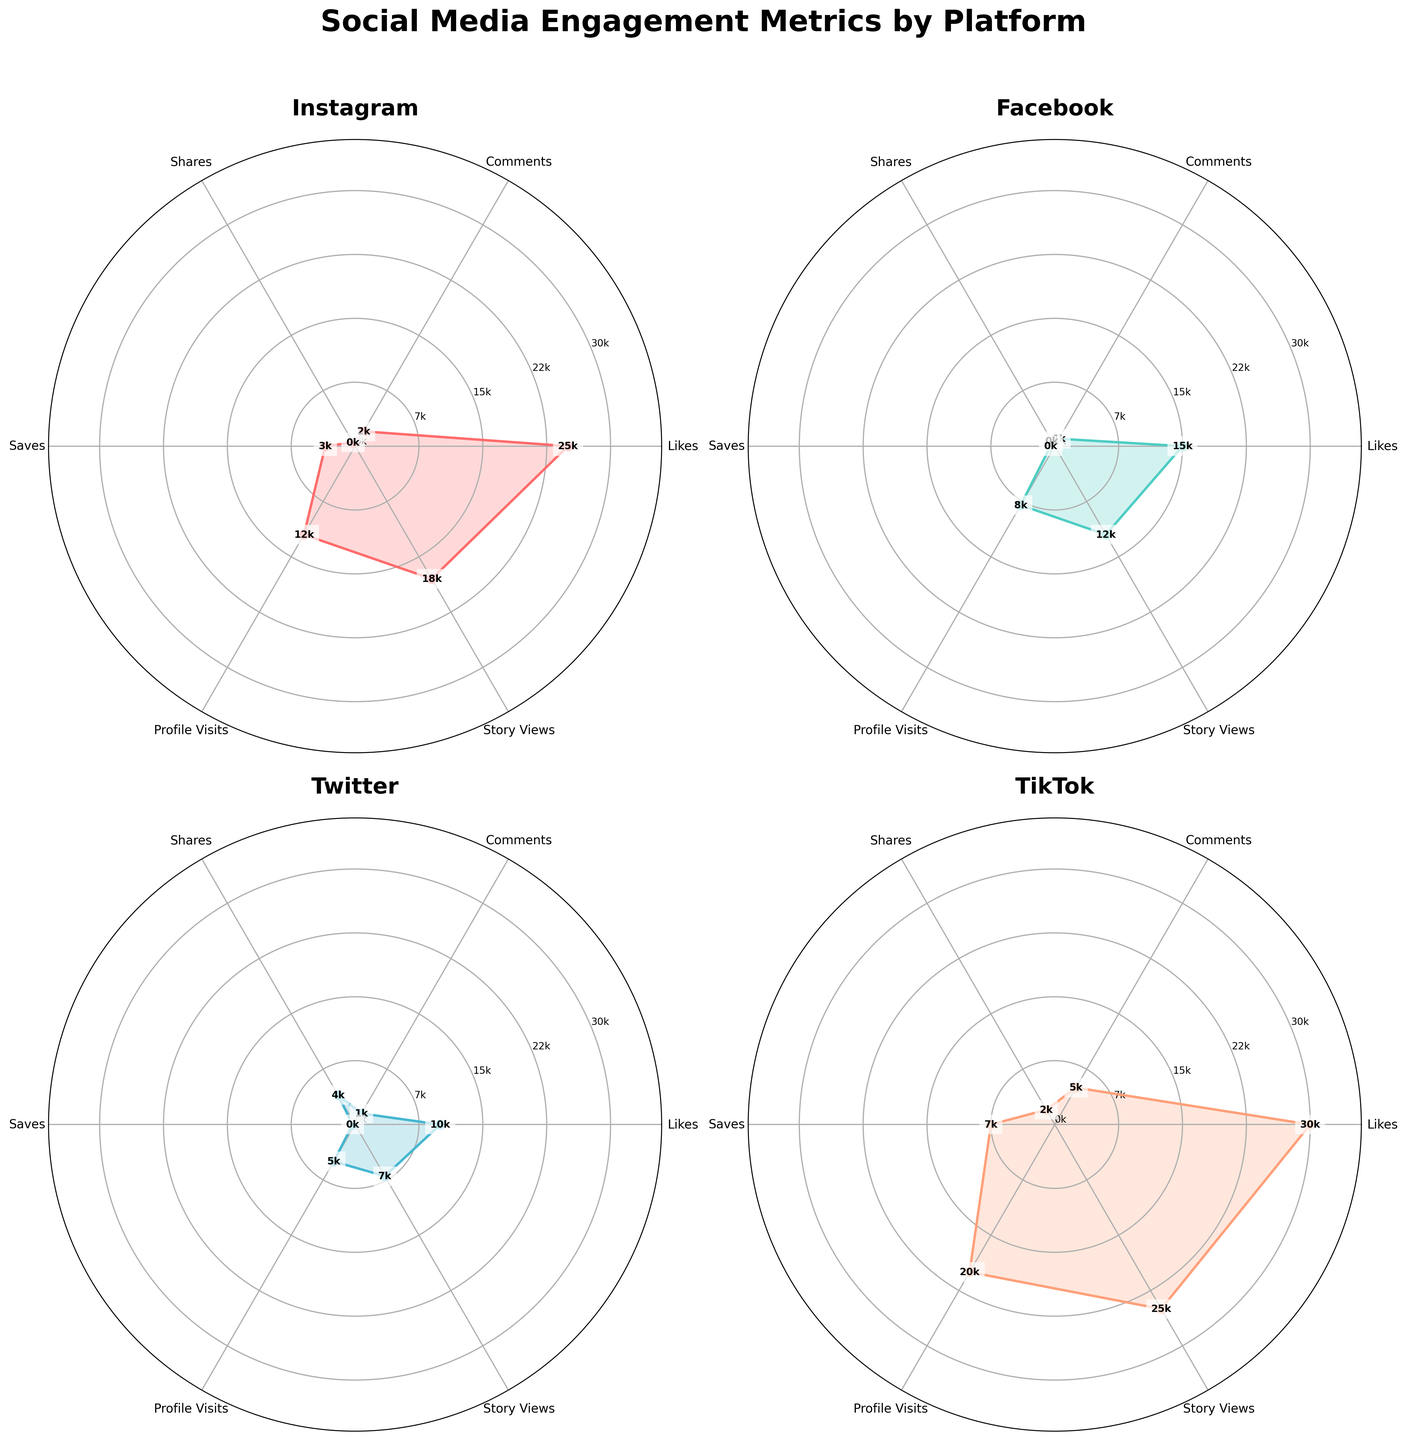What is the title of the figure? The title of the figure is located at the top and it states the general subject of the plots. It reads "Social Media Engagement Metrics by Platform".
Answer: Social Media Engagement Metrics by Platform Which platform has the highest number of likes? By observing the values around the "Likes" metric, TikTok shows the highest number with a noticeable value of 30k.
Answer: TikTok How many metrics are shown in the figure for each platform? Counting the number of distinct types of metrics around each polar plot, there are 6 metrics shown for each platform.
Answer: 6 Which platform has the most comments? Looking at the "Comments" section for each platform, TikTok boasts the highest with 5k comments.
Answer: TikTok Which metric has the lowest value on Instagram? For Instagram, checking each metric, it is evident that 'Shares' has the lowest value, marked at 500.
Answer: Shares What is the combined value of Likes and Story Views on Facebook? Adding the values observed around the "Likes" and "Story Views" metrics on Facebook, the sum is 15k (Likes) + 12k (Story Views) = 27k.
Answer: 27k How does the number of Profile Visits on Twitter compare to Instagram? By comparing the "Profile Visits" metrics, Twitter has 5k visits whereas Instagram has 12k visits, showing Instagram has more.
Answer: Instagram has more Which platform has the largest variance in its engagement metrics? Observing the spread and scale of values in the plots, TikTok has the widest range of values from 2k to 30k, indicating the largest variance.
Answer: TikTok Looking at the figure, how can you describe the engagement pattern on TikTok compared to Facebook? TikTok exhibits significantly higher maximum values across almost all metrics, showing a stronger engagement pattern compared to Facebook which has relatively smaller values.
Answer: TikTok has stronger engagement 